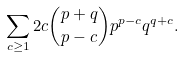<formula> <loc_0><loc_0><loc_500><loc_500>\sum _ { c \geq 1 } 2 c { p + q \choose p - c } p ^ { p - c } q ^ { q + c } .</formula> 